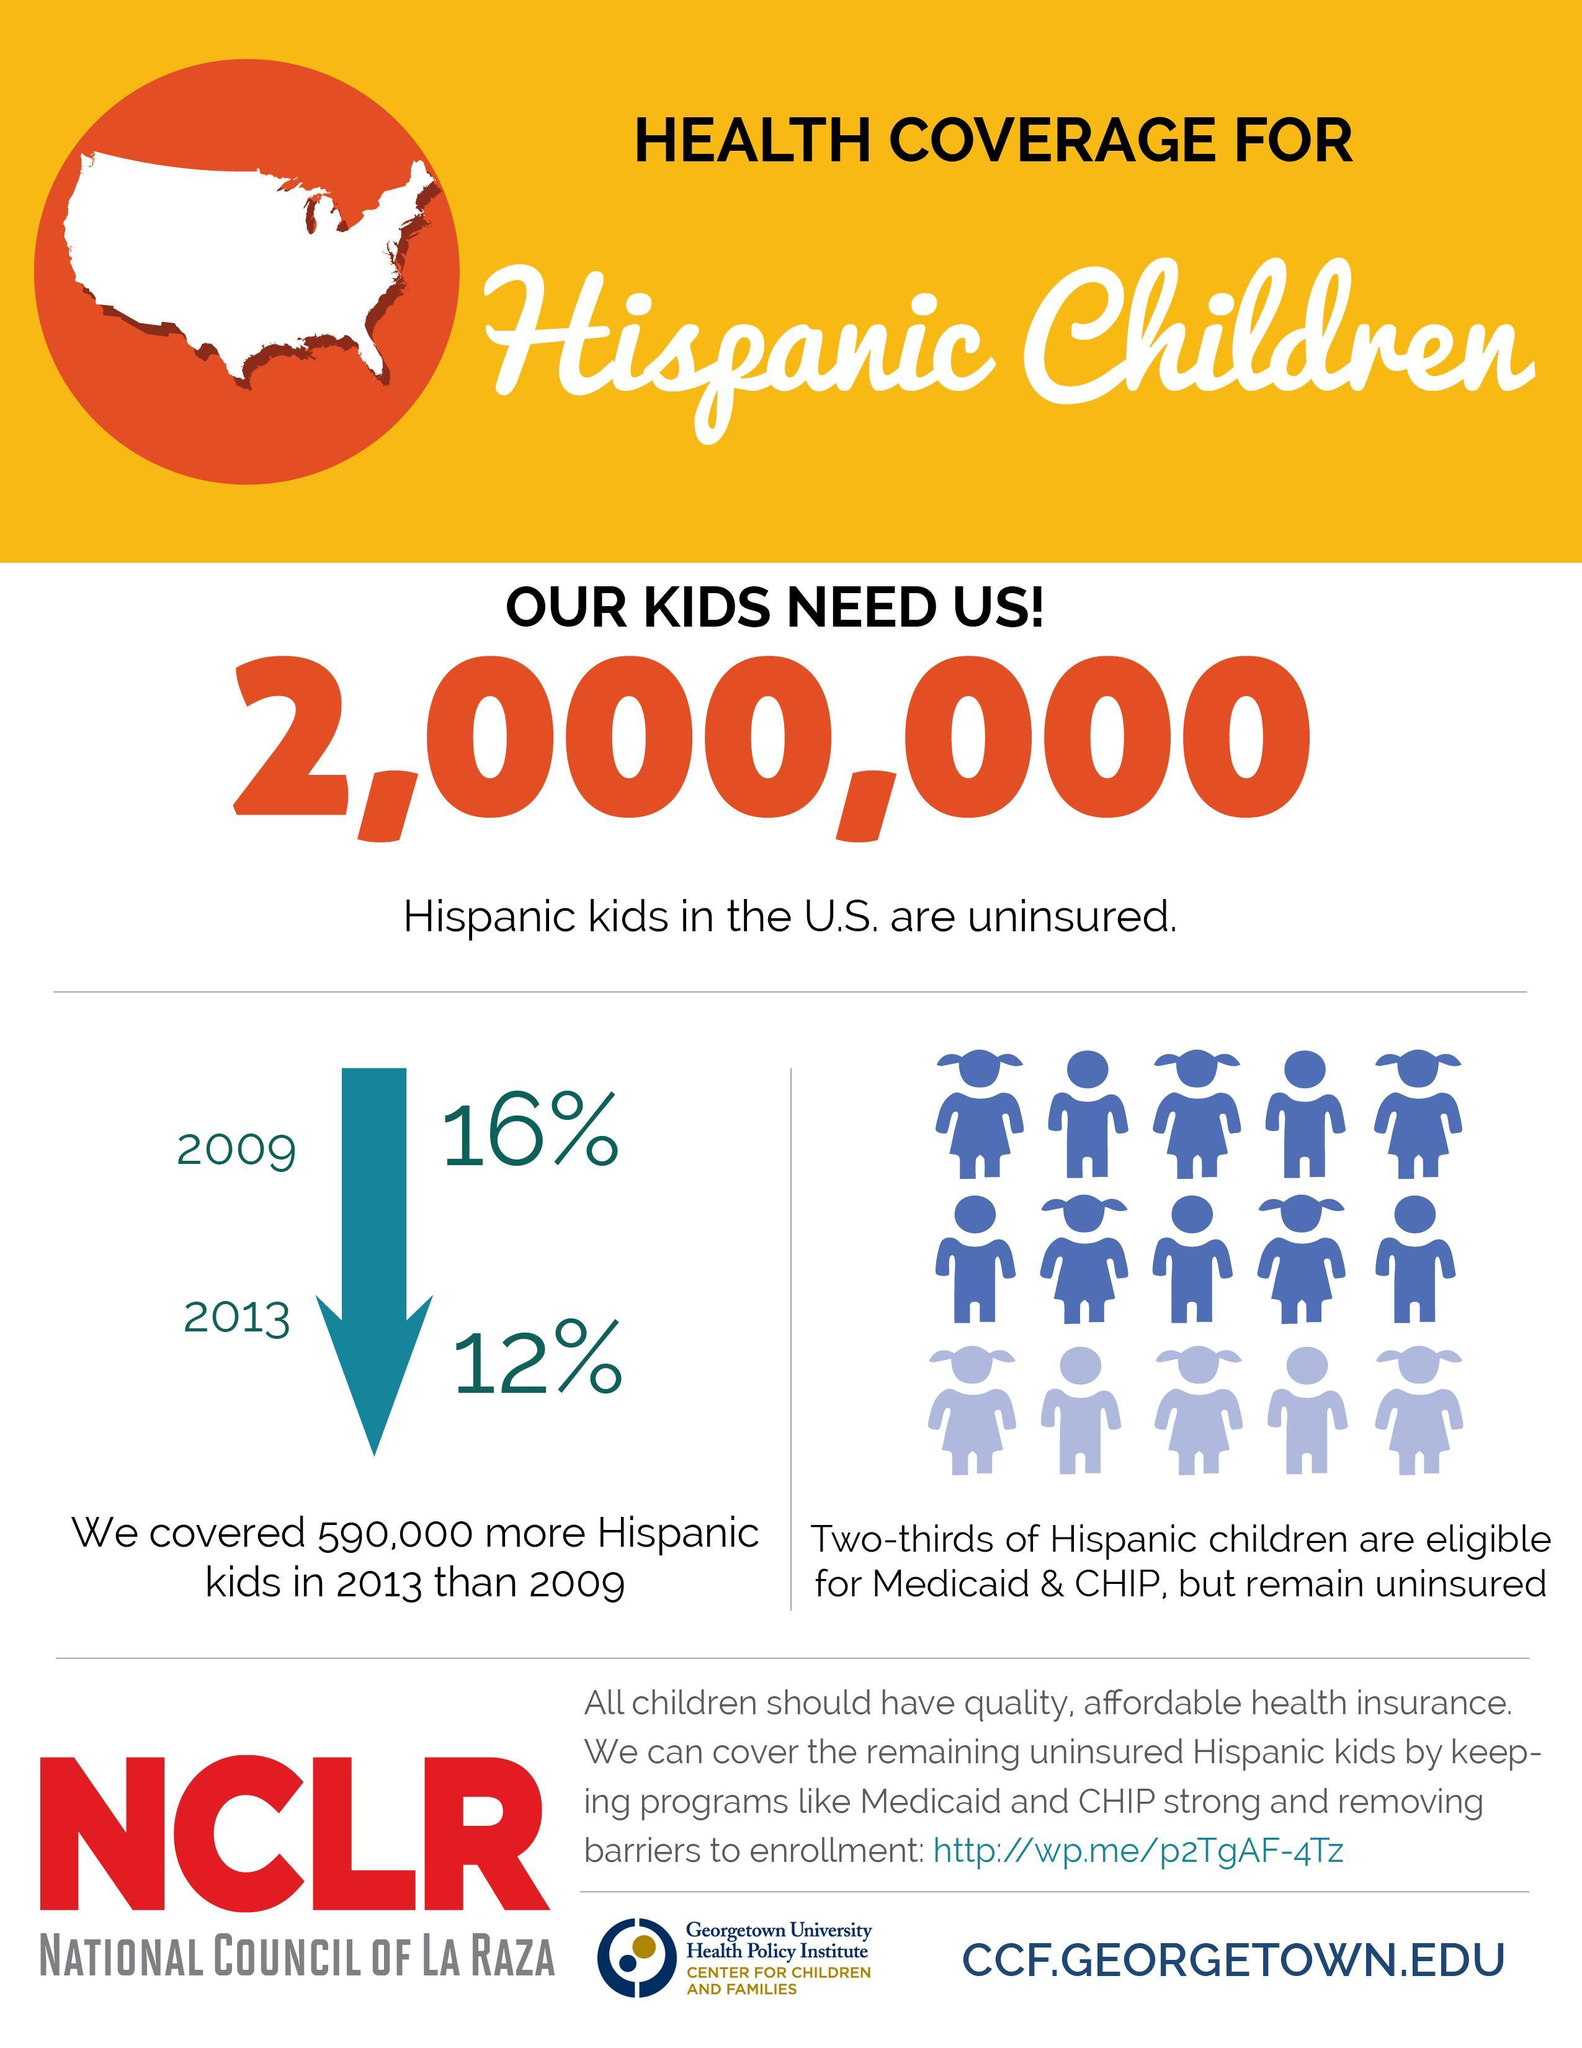What proportion of Hispanic children are insured- one-third or two-thirds?
Answer the question with a short phrase. one-third By what percentage has the number of uninsured kids reduced from 2009 to 2013/ 4% 